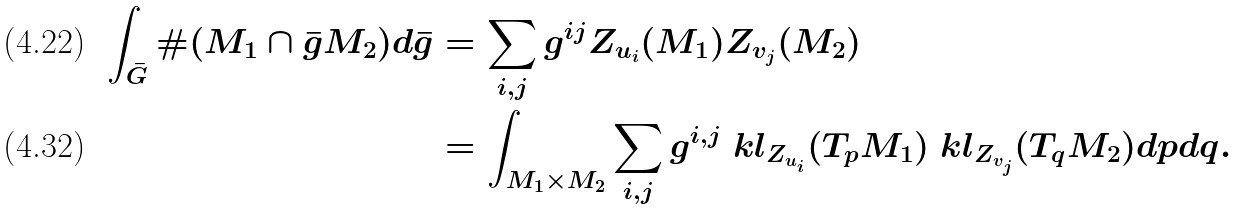<formula> <loc_0><loc_0><loc_500><loc_500>\int _ { \bar { G } } \# ( M _ { 1 } \cap \bar { g } M _ { 2 } ) d \bar { g } & = \sum _ { i , j } g ^ { i j } Z _ { u _ { i } } ( M _ { 1 } ) Z _ { v _ { j } } ( M _ { 2 } ) \\ & = \int _ { M _ { 1 } \times M _ { 2 } } \sum _ { i , j } g ^ { i , j } \ k l _ { Z _ { u _ { i } } } ( T _ { p } M _ { 1 } ) \ k l _ { Z _ { v _ { j } } } ( T _ { q } M _ { 2 } ) d p d q .</formula> 